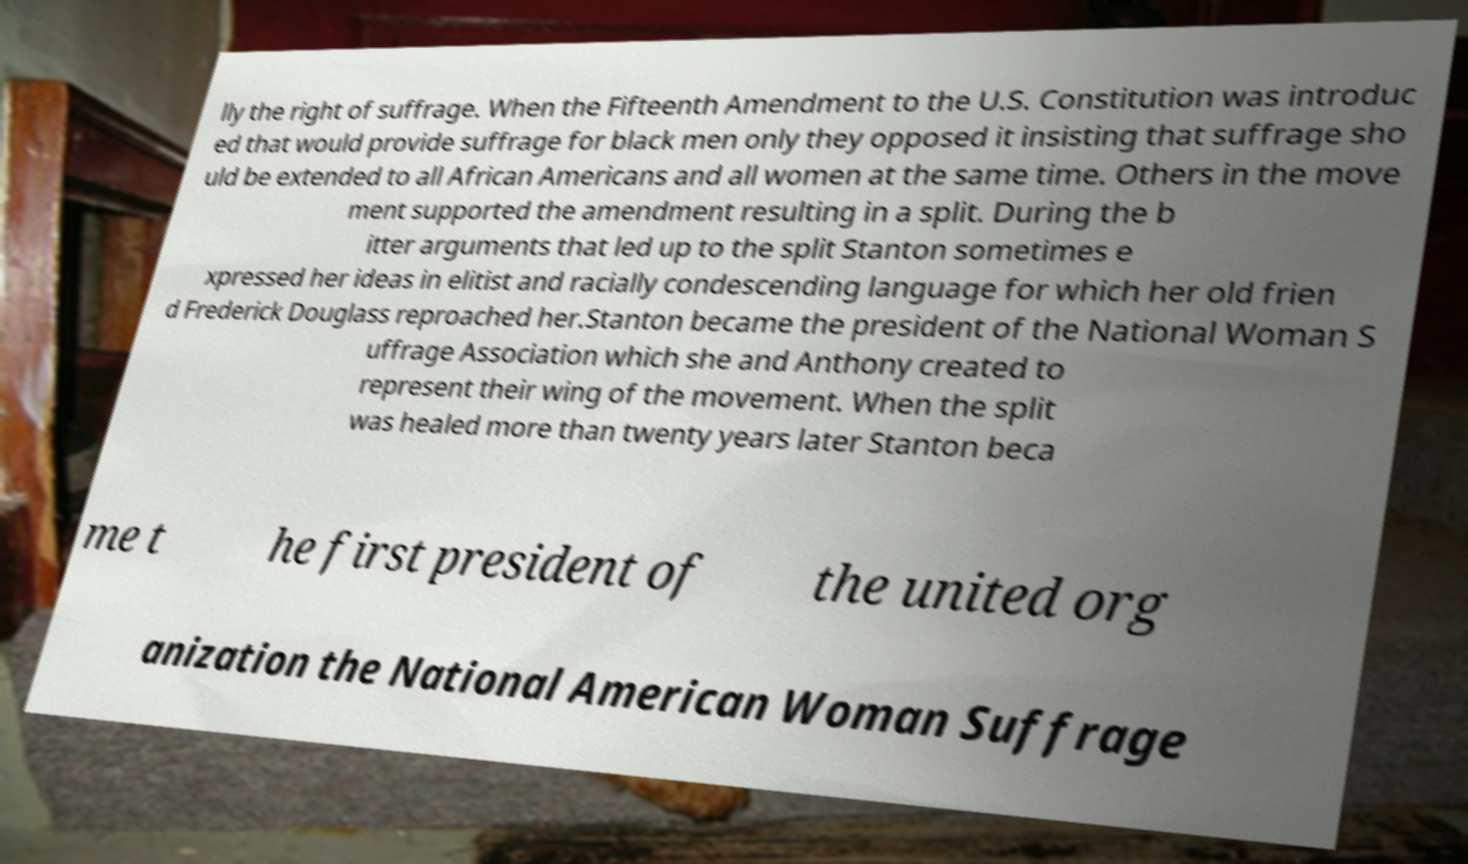For documentation purposes, I need the text within this image transcribed. Could you provide that? lly the right of suffrage. When the Fifteenth Amendment to the U.S. Constitution was introduc ed that would provide suffrage for black men only they opposed it insisting that suffrage sho uld be extended to all African Americans and all women at the same time. Others in the move ment supported the amendment resulting in a split. During the b itter arguments that led up to the split Stanton sometimes e xpressed her ideas in elitist and racially condescending language for which her old frien d Frederick Douglass reproached her.Stanton became the president of the National Woman S uffrage Association which she and Anthony created to represent their wing of the movement. When the split was healed more than twenty years later Stanton beca me t he first president of the united org anization the National American Woman Suffrage 